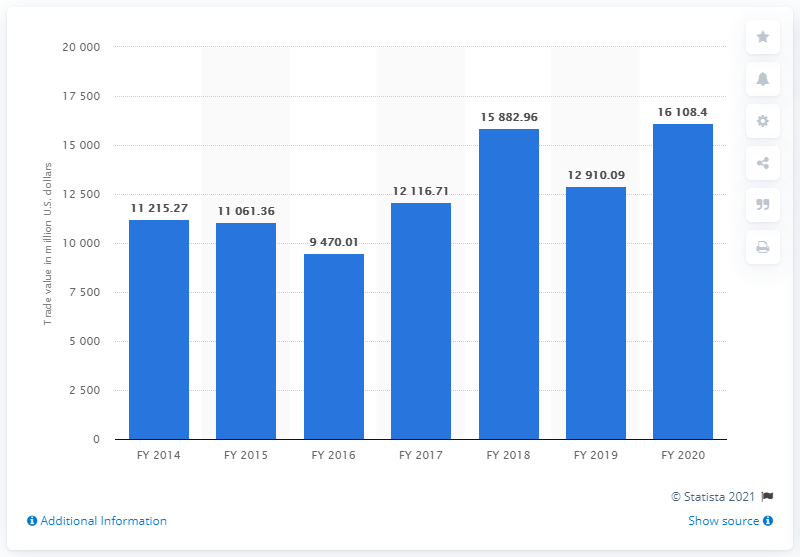Identify some key points in this picture. In the fiscal year 2020, India's trade with the Commonwealth of Independent States amounted to 16,108.4 million dollars. 